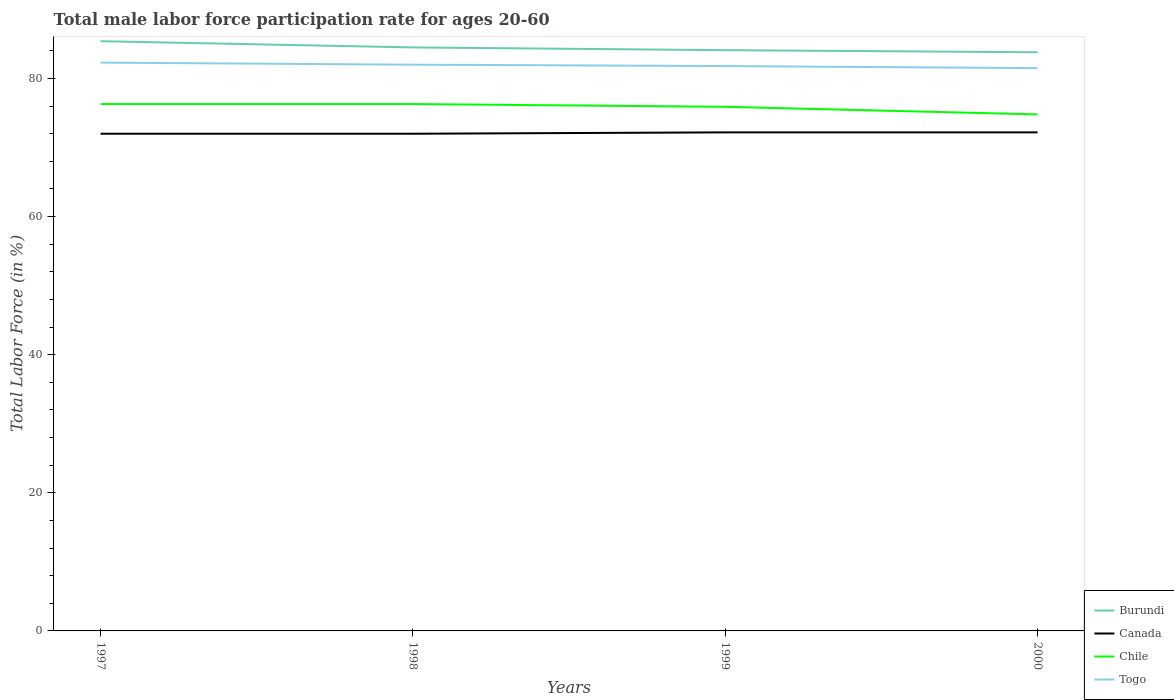How many different coloured lines are there?
Keep it short and to the point. 4. Does the line corresponding to Burundi intersect with the line corresponding to Chile?
Make the answer very short. No. Is the number of lines equal to the number of legend labels?
Make the answer very short. Yes. Across all years, what is the maximum male labor force participation rate in Burundi?
Your answer should be compact. 83.8. What is the total male labor force participation rate in Burundi in the graph?
Make the answer very short. 0.9. What is the difference between the highest and the second highest male labor force participation rate in Canada?
Provide a short and direct response. 0.2. What is the difference between the highest and the lowest male labor force participation rate in Chile?
Your answer should be compact. 3. How many years are there in the graph?
Your response must be concise. 4. What is the difference between two consecutive major ticks on the Y-axis?
Your answer should be compact. 20. Does the graph contain grids?
Your response must be concise. No. Where does the legend appear in the graph?
Offer a terse response. Bottom right. How are the legend labels stacked?
Ensure brevity in your answer.  Vertical. What is the title of the graph?
Ensure brevity in your answer.  Total male labor force participation rate for ages 20-60. What is the label or title of the X-axis?
Offer a terse response. Years. What is the label or title of the Y-axis?
Offer a terse response. Total Labor Force (in %). What is the Total Labor Force (in %) of Burundi in 1997?
Give a very brief answer. 85.4. What is the Total Labor Force (in %) of Chile in 1997?
Make the answer very short. 76.3. What is the Total Labor Force (in %) of Togo in 1997?
Make the answer very short. 82.3. What is the Total Labor Force (in %) in Burundi in 1998?
Your answer should be compact. 84.5. What is the Total Labor Force (in %) of Canada in 1998?
Offer a very short reply. 72. What is the Total Labor Force (in %) of Chile in 1998?
Your response must be concise. 76.3. What is the Total Labor Force (in %) of Togo in 1998?
Make the answer very short. 82. What is the Total Labor Force (in %) of Burundi in 1999?
Your response must be concise. 84.1. What is the Total Labor Force (in %) of Canada in 1999?
Make the answer very short. 72.2. What is the Total Labor Force (in %) in Chile in 1999?
Ensure brevity in your answer.  75.9. What is the Total Labor Force (in %) of Togo in 1999?
Offer a terse response. 81.8. What is the Total Labor Force (in %) of Burundi in 2000?
Offer a very short reply. 83.8. What is the Total Labor Force (in %) of Canada in 2000?
Provide a succinct answer. 72.2. What is the Total Labor Force (in %) in Chile in 2000?
Keep it short and to the point. 74.8. What is the Total Labor Force (in %) in Togo in 2000?
Offer a terse response. 81.5. Across all years, what is the maximum Total Labor Force (in %) in Burundi?
Give a very brief answer. 85.4. Across all years, what is the maximum Total Labor Force (in %) of Canada?
Your response must be concise. 72.2. Across all years, what is the maximum Total Labor Force (in %) in Chile?
Give a very brief answer. 76.3. Across all years, what is the maximum Total Labor Force (in %) of Togo?
Offer a very short reply. 82.3. Across all years, what is the minimum Total Labor Force (in %) of Burundi?
Ensure brevity in your answer.  83.8. Across all years, what is the minimum Total Labor Force (in %) in Chile?
Make the answer very short. 74.8. Across all years, what is the minimum Total Labor Force (in %) in Togo?
Make the answer very short. 81.5. What is the total Total Labor Force (in %) of Burundi in the graph?
Give a very brief answer. 337.8. What is the total Total Labor Force (in %) of Canada in the graph?
Your response must be concise. 288.4. What is the total Total Labor Force (in %) of Chile in the graph?
Your response must be concise. 303.3. What is the total Total Labor Force (in %) in Togo in the graph?
Your response must be concise. 327.6. What is the difference between the Total Labor Force (in %) in Burundi in 1997 and that in 1998?
Provide a short and direct response. 0.9. What is the difference between the Total Labor Force (in %) of Togo in 1997 and that in 1998?
Your answer should be very brief. 0.3. What is the difference between the Total Labor Force (in %) of Burundi in 1997 and that in 1999?
Give a very brief answer. 1.3. What is the difference between the Total Labor Force (in %) of Chile in 1998 and that in 1999?
Give a very brief answer. 0.4. What is the difference between the Total Labor Force (in %) of Togo in 1998 and that in 1999?
Your answer should be compact. 0.2. What is the difference between the Total Labor Force (in %) in Togo in 1998 and that in 2000?
Provide a short and direct response. 0.5. What is the difference between the Total Labor Force (in %) of Burundi in 1999 and that in 2000?
Your answer should be compact. 0.3. What is the difference between the Total Labor Force (in %) in Canada in 1999 and that in 2000?
Your answer should be very brief. 0. What is the difference between the Total Labor Force (in %) in Chile in 1999 and that in 2000?
Provide a short and direct response. 1.1. What is the difference between the Total Labor Force (in %) in Togo in 1999 and that in 2000?
Provide a succinct answer. 0.3. What is the difference between the Total Labor Force (in %) in Burundi in 1997 and the Total Labor Force (in %) in Canada in 1998?
Offer a terse response. 13.4. What is the difference between the Total Labor Force (in %) of Canada in 1997 and the Total Labor Force (in %) of Chile in 1998?
Provide a succinct answer. -4.3. What is the difference between the Total Labor Force (in %) of Canada in 1997 and the Total Labor Force (in %) of Togo in 1998?
Offer a terse response. -10. What is the difference between the Total Labor Force (in %) in Burundi in 1997 and the Total Labor Force (in %) in Togo in 1999?
Your answer should be very brief. 3.6. What is the difference between the Total Labor Force (in %) in Burundi in 1997 and the Total Labor Force (in %) in Canada in 2000?
Your response must be concise. 13.2. What is the difference between the Total Labor Force (in %) in Canada in 1997 and the Total Labor Force (in %) in Togo in 2000?
Your answer should be compact. -9.5. What is the difference between the Total Labor Force (in %) in Burundi in 1998 and the Total Labor Force (in %) in Canada in 1999?
Provide a succinct answer. 12.3. What is the difference between the Total Labor Force (in %) of Burundi in 1998 and the Total Labor Force (in %) of Chile in 1999?
Provide a short and direct response. 8.6. What is the difference between the Total Labor Force (in %) in Burundi in 1998 and the Total Labor Force (in %) in Togo in 1999?
Give a very brief answer. 2.7. What is the difference between the Total Labor Force (in %) in Canada in 1998 and the Total Labor Force (in %) in Togo in 1999?
Give a very brief answer. -9.8. What is the difference between the Total Labor Force (in %) in Chile in 1998 and the Total Labor Force (in %) in Togo in 1999?
Your answer should be compact. -5.5. What is the difference between the Total Labor Force (in %) of Burundi in 1998 and the Total Labor Force (in %) of Canada in 2000?
Your answer should be very brief. 12.3. What is the difference between the Total Labor Force (in %) of Burundi in 1998 and the Total Labor Force (in %) of Togo in 2000?
Make the answer very short. 3. What is the difference between the Total Labor Force (in %) of Burundi in 1999 and the Total Labor Force (in %) of Canada in 2000?
Make the answer very short. 11.9. What is the difference between the Total Labor Force (in %) of Burundi in 1999 and the Total Labor Force (in %) of Togo in 2000?
Offer a very short reply. 2.6. What is the difference between the Total Labor Force (in %) in Canada in 1999 and the Total Labor Force (in %) in Chile in 2000?
Offer a very short reply. -2.6. What is the difference between the Total Labor Force (in %) in Canada in 1999 and the Total Labor Force (in %) in Togo in 2000?
Your answer should be compact. -9.3. What is the average Total Labor Force (in %) in Burundi per year?
Ensure brevity in your answer.  84.45. What is the average Total Labor Force (in %) of Canada per year?
Your response must be concise. 72.1. What is the average Total Labor Force (in %) of Chile per year?
Offer a terse response. 75.83. What is the average Total Labor Force (in %) of Togo per year?
Your response must be concise. 81.9. In the year 1997, what is the difference between the Total Labor Force (in %) of Burundi and Total Labor Force (in %) of Chile?
Ensure brevity in your answer.  9.1. In the year 1997, what is the difference between the Total Labor Force (in %) of Canada and Total Labor Force (in %) of Chile?
Make the answer very short. -4.3. In the year 1997, what is the difference between the Total Labor Force (in %) in Canada and Total Labor Force (in %) in Togo?
Give a very brief answer. -10.3. In the year 1998, what is the difference between the Total Labor Force (in %) of Burundi and Total Labor Force (in %) of Canada?
Your response must be concise. 12.5. In the year 1998, what is the difference between the Total Labor Force (in %) of Canada and Total Labor Force (in %) of Togo?
Your answer should be very brief. -10. In the year 1999, what is the difference between the Total Labor Force (in %) of Burundi and Total Labor Force (in %) of Canada?
Keep it short and to the point. 11.9. In the year 1999, what is the difference between the Total Labor Force (in %) in Burundi and Total Labor Force (in %) in Chile?
Make the answer very short. 8.2. In the year 1999, what is the difference between the Total Labor Force (in %) in Canada and Total Labor Force (in %) in Chile?
Your answer should be compact. -3.7. In the year 1999, what is the difference between the Total Labor Force (in %) in Chile and Total Labor Force (in %) in Togo?
Your response must be concise. -5.9. In the year 2000, what is the difference between the Total Labor Force (in %) of Burundi and Total Labor Force (in %) of Chile?
Provide a succinct answer. 9. In the year 2000, what is the difference between the Total Labor Force (in %) of Canada and Total Labor Force (in %) of Chile?
Provide a succinct answer. -2.6. In the year 2000, what is the difference between the Total Labor Force (in %) in Canada and Total Labor Force (in %) in Togo?
Ensure brevity in your answer.  -9.3. In the year 2000, what is the difference between the Total Labor Force (in %) in Chile and Total Labor Force (in %) in Togo?
Your answer should be compact. -6.7. What is the ratio of the Total Labor Force (in %) of Burundi in 1997 to that in 1998?
Ensure brevity in your answer.  1.01. What is the ratio of the Total Labor Force (in %) of Chile in 1997 to that in 1998?
Your response must be concise. 1. What is the ratio of the Total Labor Force (in %) of Burundi in 1997 to that in 1999?
Your response must be concise. 1.02. What is the ratio of the Total Labor Force (in %) of Chile in 1997 to that in 1999?
Your answer should be very brief. 1.01. What is the ratio of the Total Labor Force (in %) in Togo in 1997 to that in 1999?
Your answer should be compact. 1.01. What is the ratio of the Total Labor Force (in %) of Burundi in 1997 to that in 2000?
Provide a short and direct response. 1.02. What is the ratio of the Total Labor Force (in %) of Chile in 1997 to that in 2000?
Offer a very short reply. 1.02. What is the ratio of the Total Labor Force (in %) in Togo in 1997 to that in 2000?
Offer a very short reply. 1.01. What is the ratio of the Total Labor Force (in %) in Burundi in 1998 to that in 1999?
Offer a terse response. 1. What is the ratio of the Total Labor Force (in %) of Canada in 1998 to that in 1999?
Make the answer very short. 1. What is the ratio of the Total Labor Force (in %) in Burundi in 1998 to that in 2000?
Your answer should be compact. 1.01. What is the ratio of the Total Labor Force (in %) of Chile in 1998 to that in 2000?
Give a very brief answer. 1.02. What is the ratio of the Total Labor Force (in %) in Burundi in 1999 to that in 2000?
Give a very brief answer. 1. What is the ratio of the Total Labor Force (in %) in Chile in 1999 to that in 2000?
Keep it short and to the point. 1.01. What is the difference between the highest and the second highest Total Labor Force (in %) in Canada?
Keep it short and to the point. 0. What is the difference between the highest and the lowest Total Labor Force (in %) of Burundi?
Provide a short and direct response. 1.6. What is the difference between the highest and the lowest Total Labor Force (in %) in Chile?
Offer a terse response. 1.5. 